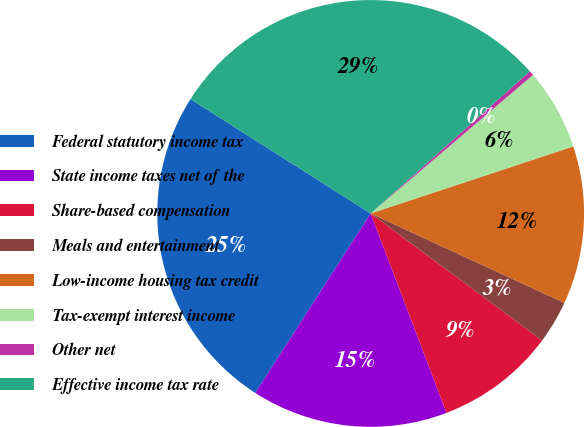<chart> <loc_0><loc_0><loc_500><loc_500><pie_chart><fcel>Federal statutory income tax<fcel>State income taxes net of the<fcel>Share-based compensation<fcel>Meals and entertainment<fcel>Low-income housing tax credit<fcel>Tax-exempt interest income<fcel>Other net<fcel>Effective income tax rate<nl><fcel>24.91%<fcel>14.88%<fcel>9.07%<fcel>3.26%<fcel>11.97%<fcel>6.16%<fcel>0.36%<fcel>29.4%<nl></chart> 